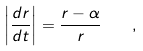Convert formula to latex. <formula><loc_0><loc_0><loc_500><loc_500>\left | \frac { d r } { d t } \right | = \frac { r - \alpha } { r } \quad ,</formula> 